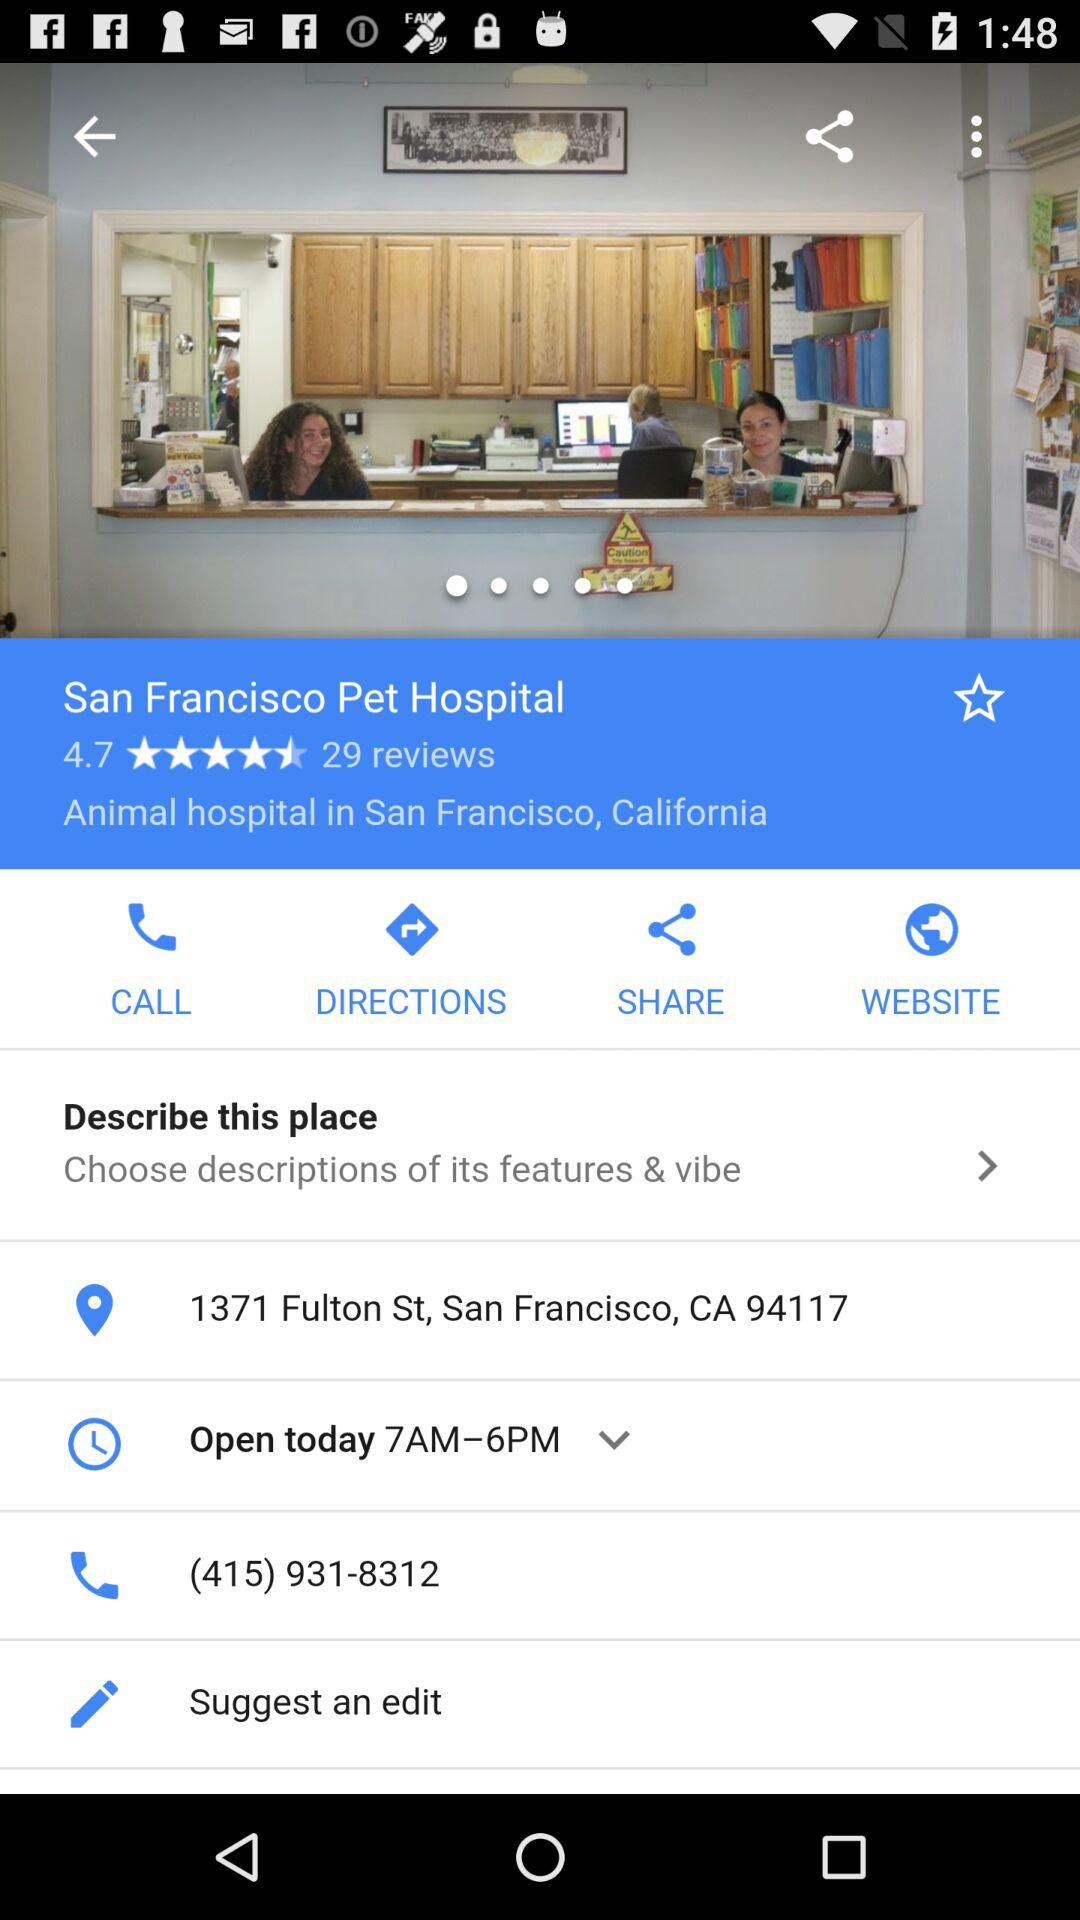What is the rating of the San Francisco Pet Hospital? The rating is 4.7 stars. 